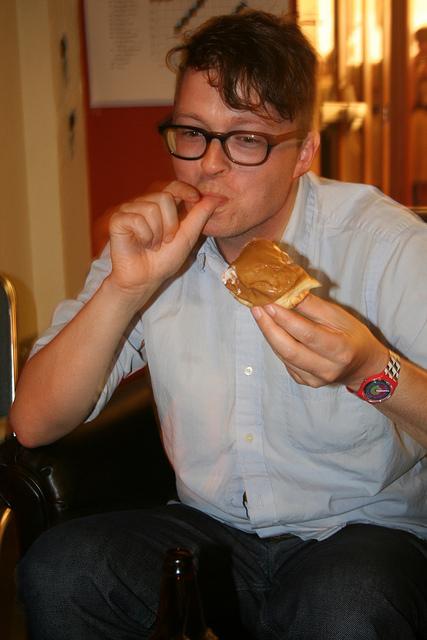Is this man's shirt clean?
Quick response, please. Yes. What does he have in his mouth?
Write a very short answer. Thumb. What sort of condiments does the man like?
Short answer required. Peanut butter. Does this gentleman need to shave?
Short answer required. No. Wristwatch, bracelet or fitness tracker?
Concise answer only. Wristwatch. What kind of food is this?
Give a very brief answer. Pie. Is this person wearing a ring?
Write a very short answer. No. Is this man bald?
Answer briefly. No. What is the boy holding?
Short answer required. Food. Does this man need a haircut?
Give a very brief answer. No. Is the man pointing at the camera?
Keep it brief. No. What is this man eating?
Short answer required. Donut. Is the man smiling?
Keep it brief. No. What this man eating?
Keep it brief. Donut. What is the man stuffing in his mouth?
Be succinct. Food. What color is the man's hat?
Write a very short answer. No hat. What is the woman eating with her hands?
Write a very short answer. Cake. What is the man doing in this photo?
Short answer required. Eating. What is he sitting in?
Keep it brief. Chair. What is the man eating?
Quick response, please. Pie. Is the man wearing a ring?
Be succinct. No. What kind of vegetable is on the sandwich?
Short answer required. None. These kind of glasses frames are popular with what modern subculture?
Write a very short answer. Nerds. 